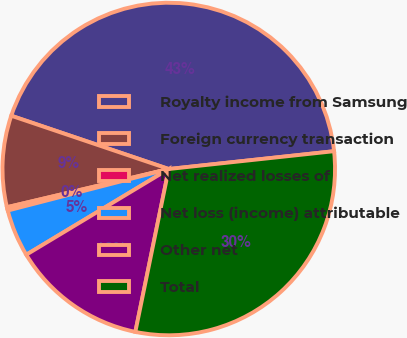Convert chart to OTSL. <chart><loc_0><loc_0><loc_500><loc_500><pie_chart><fcel>Royalty income from Samsung<fcel>Foreign currency transaction<fcel>Net realized losses of<fcel>Net loss (income) attributable<fcel>Other net<fcel>Total<nl><fcel>43.1%<fcel>8.88%<fcel>0.33%<fcel>4.6%<fcel>13.16%<fcel>29.93%<nl></chart> 